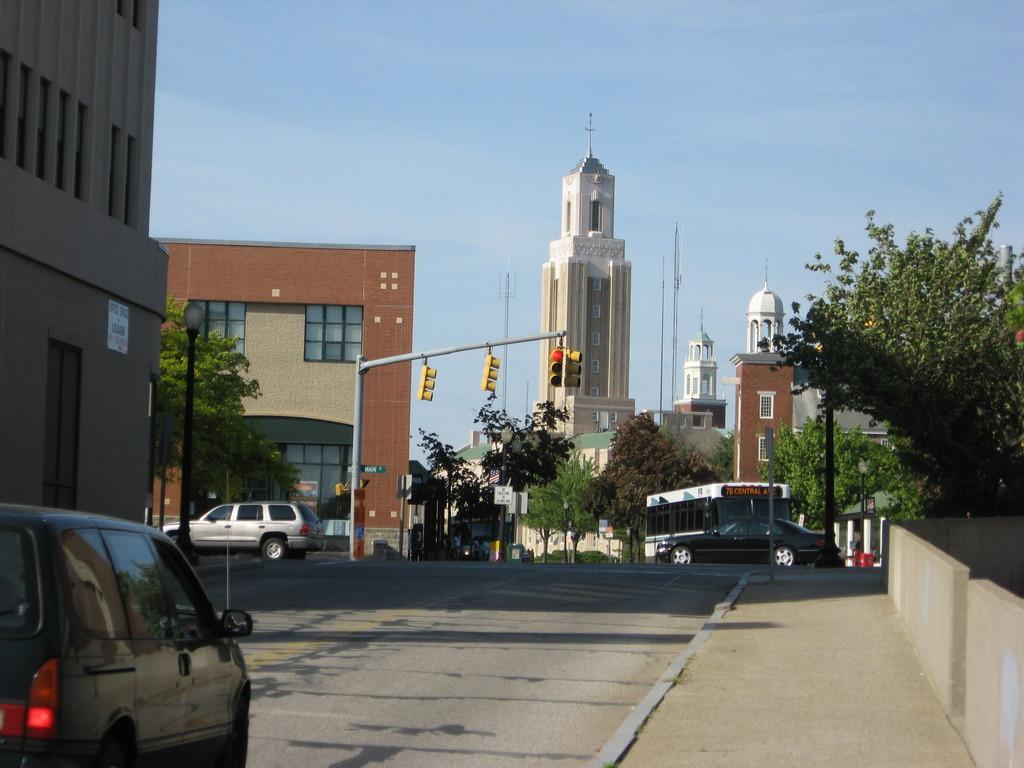What type of structures can be seen in the image? There are many buildings in the image. What other elements can be seen in the image besides buildings? There are plants, poles, street lights, a traffic signal, and cars on the road in the image. What is visible at the top of the image? The sky is visible at the top of the image, and clouds are present in the sky. What type of protest is happening in the room depicted in the image? There is no room or protest depicted in the image; it features an urban scene with buildings, plants, poles, street lights, a traffic signal, cars, and a sky with clouds. Where is the train station located in the image? There is no train station present in the image. 